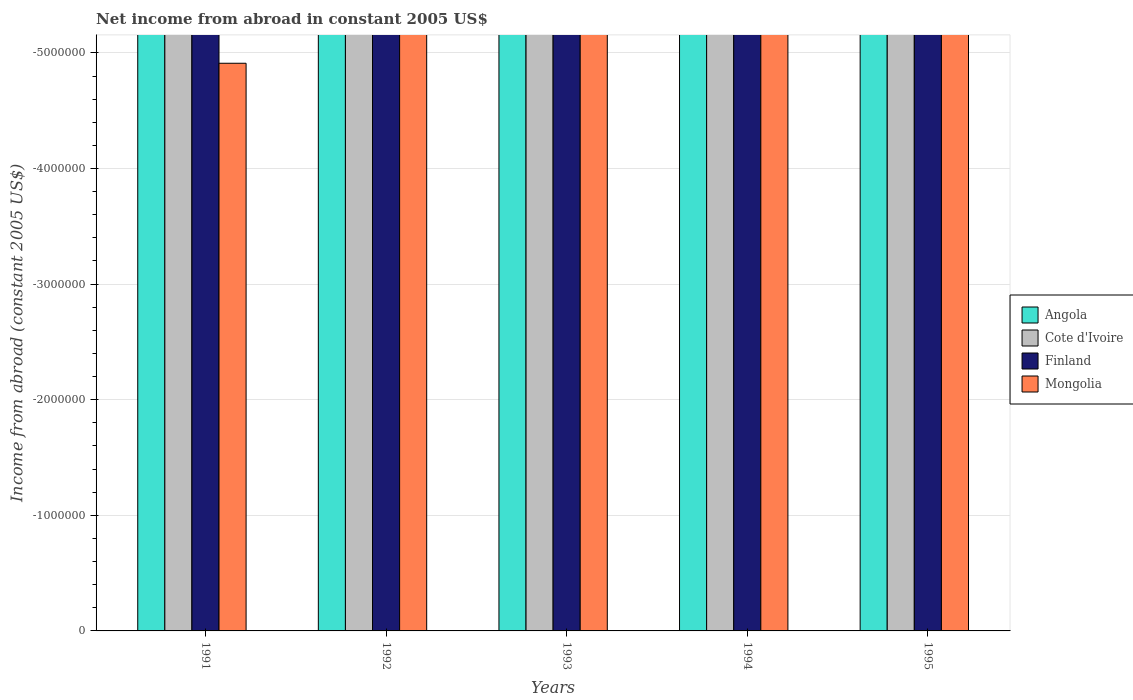Are the number of bars on each tick of the X-axis equal?
Make the answer very short. Yes. How many bars are there on the 5th tick from the left?
Keep it short and to the point. 0. How many bars are there on the 4th tick from the right?
Give a very brief answer. 0. In how many cases, is the number of bars for a given year not equal to the number of legend labels?
Ensure brevity in your answer.  5. What is the total net income from abroad in Angola in the graph?
Ensure brevity in your answer.  0. What is the difference between the net income from abroad in Mongolia in 1994 and the net income from abroad in Finland in 1995?
Provide a short and direct response. 0. What is the average net income from abroad in Cote d'Ivoire per year?
Provide a short and direct response. 0. In how many years, is the net income from abroad in Mongolia greater than the average net income from abroad in Mongolia taken over all years?
Your response must be concise. 0. Is it the case that in every year, the sum of the net income from abroad in Finland and net income from abroad in Cote d'Ivoire is greater than the sum of net income from abroad in Angola and net income from abroad in Mongolia?
Provide a short and direct response. No. Is it the case that in every year, the sum of the net income from abroad in Cote d'Ivoire and net income from abroad in Finland is greater than the net income from abroad in Mongolia?
Make the answer very short. No. How many years are there in the graph?
Make the answer very short. 5. Are the values on the major ticks of Y-axis written in scientific E-notation?
Provide a short and direct response. No. Where does the legend appear in the graph?
Provide a short and direct response. Center right. How are the legend labels stacked?
Offer a terse response. Vertical. What is the title of the graph?
Offer a terse response. Net income from abroad in constant 2005 US$. Does "Barbados" appear as one of the legend labels in the graph?
Keep it short and to the point. No. What is the label or title of the X-axis?
Your response must be concise. Years. What is the label or title of the Y-axis?
Offer a terse response. Income from abroad (constant 2005 US$). What is the Income from abroad (constant 2005 US$) of Finland in 1991?
Your answer should be compact. 0. What is the Income from abroad (constant 2005 US$) of Angola in 1992?
Your response must be concise. 0. What is the Income from abroad (constant 2005 US$) in Cote d'Ivoire in 1992?
Give a very brief answer. 0. What is the Income from abroad (constant 2005 US$) in Finland in 1992?
Offer a very short reply. 0. What is the Income from abroad (constant 2005 US$) of Finland in 1993?
Offer a terse response. 0. What is the Income from abroad (constant 2005 US$) in Angola in 1994?
Your response must be concise. 0. What is the Income from abroad (constant 2005 US$) of Cote d'Ivoire in 1994?
Ensure brevity in your answer.  0. What is the Income from abroad (constant 2005 US$) of Finland in 1994?
Keep it short and to the point. 0. What is the Income from abroad (constant 2005 US$) in Mongolia in 1994?
Provide a short and direct response. 0. What is the Income from abroad (constant 2005 US$) in Finland in 1995?
Offer a very short reply. 0. What is the Income from abroad (constant 2005 US$) of Mongolia in 1995?
Make the answer very short. 0. What is the total Income from abroad (constant 2005 US$) of Cote d'Ivoire in the graph?
Your answer should be compact. 0. What is the average Income from abroad (constant 2005 US$) in Cote d'Ivoire per year?
Give a very brief answer. 0. What is the average Income from abroad (constant 2005 US$) in Finland per year?
Give a very brief answer. 0. What is the average Income from abroad (constant 2005 US$) in Mongolia per year?
Your answer should be compact. 0. 